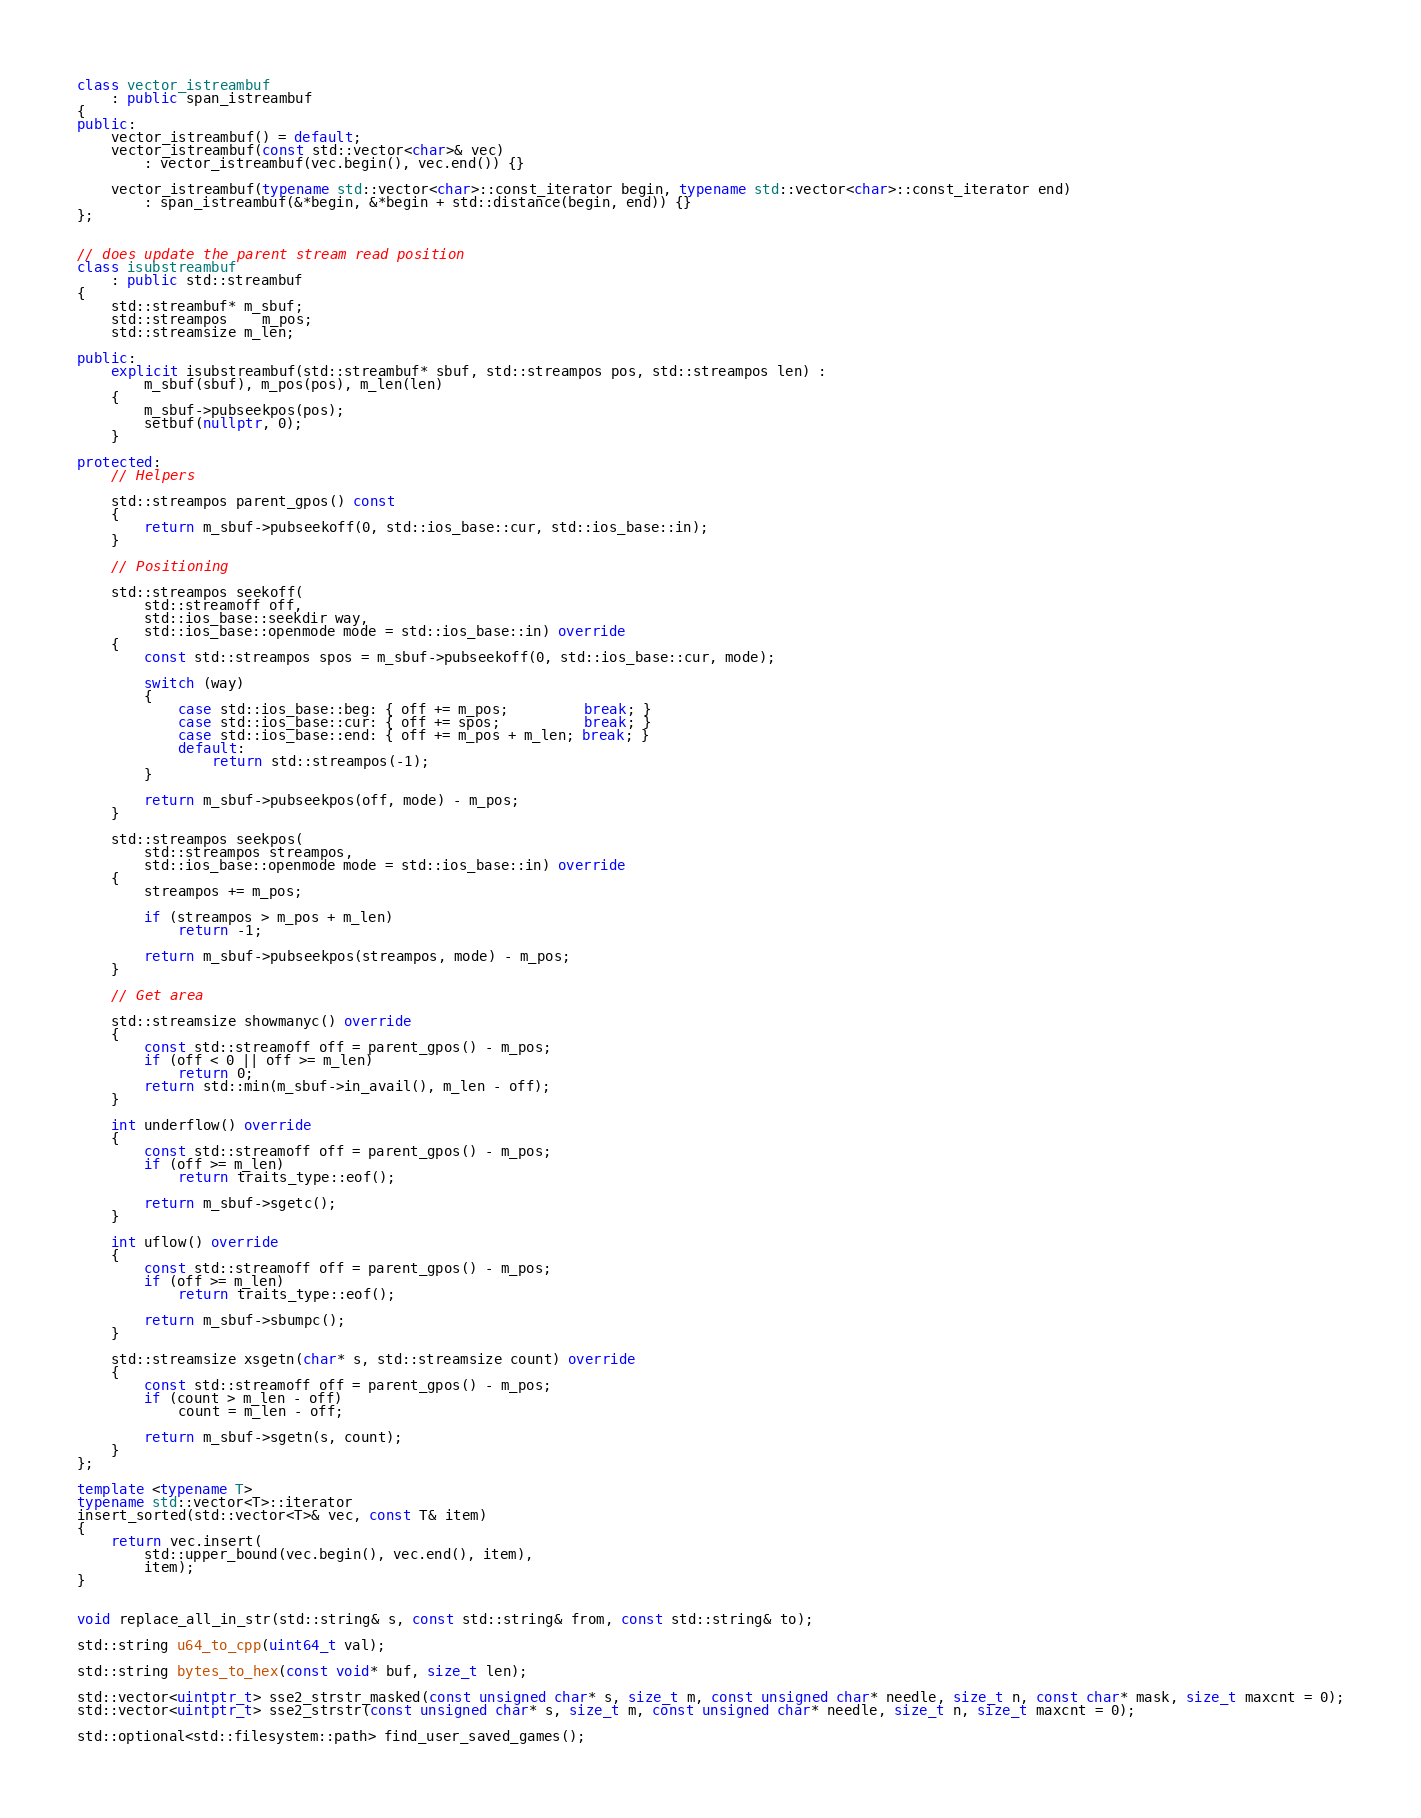<code> <loc_0><loc_0><loc_500><loc_500><_C++_>
class vector_istreambuf
	: public span_istreambuf
{
public:
	vector_istreambuf() = default;
	vector_istreambuf(const std::vector<char>& vec)
		: vector_istreambuf(vec.begin(), vec.end()) {}

	vector_istreambuf(typename std::vector<char>::const_iterator begin, typename std::vector<char>::const_iterator end)
		: span_istreambuf(&*begin, &*begin + std::distance(begin, end)) {}
};


// does update the parent stream read position
class isubstreambuf
	: public std::streambuf
{
	std::streambuf* m_sbuf;
	std::streampos	m_pos;
	std::streamsize m_len;

public:
	explicit isubstreambuf(std::streambuf* sbuf, std::streampos pos, std::streampos len) :
		m_sbuf(sbuf), m_pos(pos), m_len(len)
	{
		m_sbuf->pubseekpos(pos);
		setbuf(nullptr, 0);
	}

protected:
	// Helpers

	std::streampos parent_gpos() const
	{
		return m_sbuf->pubseekoff(0, std::ios_base::cur, std::ios_base::in);
	}

	// Positioning 

	std::streampos seekoff(
		std::streamoff off,
		std::ios_base::seekdir way,
		std::ios_base::openmode mode = std::ios_base::in) override
	{
		const std::streampos spos = m_sbuf->pubseekoff(0, std::ios_base::cur, mode);

		switch (way)
		{
			case std::ios_base::beg: { off += m_pos;         break; }
			case std::ios_base::cur: { off += spos;          break; }
			case std::ios_base::end: { off += m_pos + m_len; break; }
			default:
				return std::streampos(-1);
		}

		return m_sbuf->pubseekpos(off, mode) - m_pos;
	}

	std::streampos seekpos(
		std::streampos streampos,
		std::ios_base::openmode mode = std::ios_base::in) override
	{
		streampos += m_pos;

		if (streampos > m_pos + m_len)
			return -1;

		return m_sbuf->pubseekpos(streampos, mode) - m_pos;
	}

	// Get area

	std::streamsize showmanyc() override
	{
		const std::streamoff off = parent_gpos() - m_pos;
		if (off < 0 || off >= m_len)
			return 0;
		return std::min(m_sbuf->in_avail(), m_len - off);
	}

	int underflow() override
	{
		const std::streamoff off = parent_gpos() - m_pos;
		if (off >= m_len)
			return traits_type::eof();

		return m_sbuf->sgetc();
	}

	int uflow() override
	{
		const std::streamoff off = parent_gpos() - m_pos;
		if (off >= m_len)
			return traits_type::eof();

		return m_sbuf->sbumpc();
	}

	std::streamsize xsgetn(char* s, std::streamsize count) override
	{
		const std::streamoff off = parent_gpos() - m_pos;
		if (count > m_len - off)
			count = m_len - off;

		return m_sbuf->sgetn(s, count);
	}
};

template <typename T>
typename std::vector<T>::iterator 
insert_sorted(std::vector<T>& vec, const T& item)
{
	return vec.insert( 
		std::upper_bound(vec.begin(), vec.end(), item),
		item);
}


void replace_all_in_str(std::string& s, const std::string& from, const std::string& to);

std::string u64_to_cpp(uint64_t val);

std::string bytes_to_hex(const void* buf, size_t len);

std::vector<uintptr_t> sse2_strstr_masked(const unsigned char* s, size_t m, const unsigned char* needle, size_t n, const char* mask, size_t maxcnt = 0);
std::vector<uintptr_t> sse2_strstr(const unsigned char* s, size_t m, const unsigned char* needle, size_t n, size_t maxcnt = 0);

std::optional<std::filesystem::path> find_user_saved_games();

</code> 